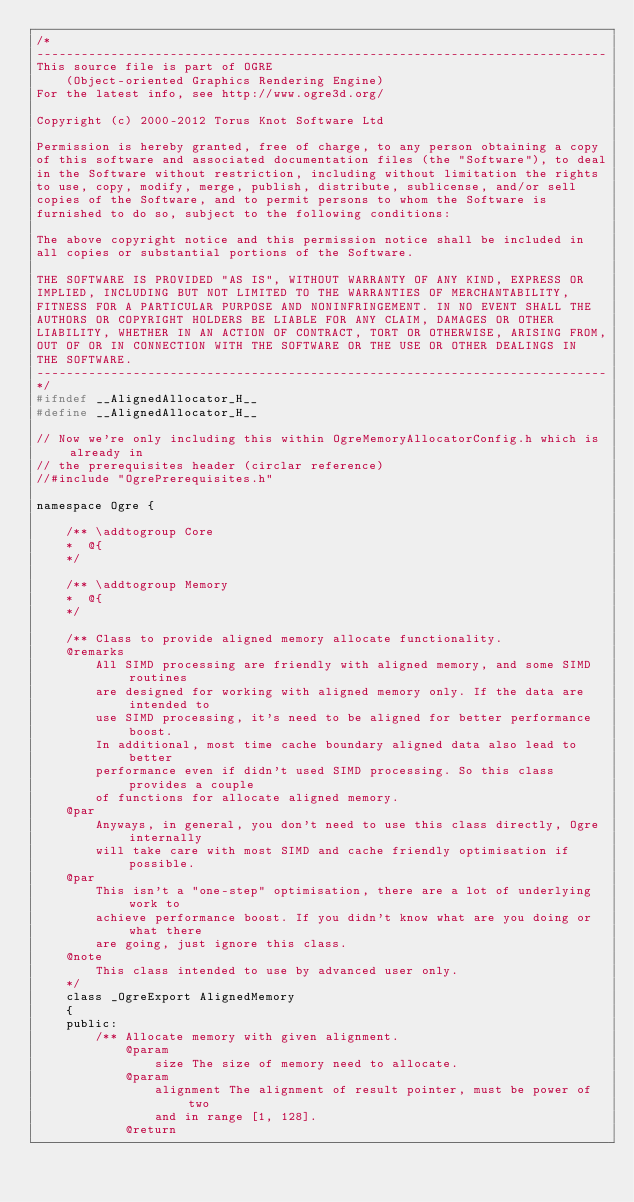Convert code to text. <code><loc_0><loc_0><loc_500><loc_500><_C_>/*
-----------------------------------------------------------------------------
This source file is part of OGRE
    (Object-oriented Graphics Rendering Engine)
For the latest info, see http://www.ogre3d.org/

Copyright (c) 2000-2012 Torus Knot Software Ltd

Permission is hereby granted, free of charge, to any person obtaining a copy
of this software and associated documentation files (the "Software"), to deal
in the Software without restriction, including without limitation the rights
to use, copy, modify, merge, publish, distribute, sublicense, and/or sell
copies of the Software, and to permit persons to whom the Software is
furnished to do so, subject to the following conditions:

The above copyright notice and this permission notice shall be included in
all copies or substantial portions of the Software.

THE SOFTWARE IS PROVIDED "AS IS", WITHOUT WARRANTY OF ANY KIND, EXPRESS OR
IMPLIED, INCLUDING BUT NOT LIMITED TO THE WARRANTIES OF MERCHANTABILITY,
FITNESS FOR A PARTICULAR PURPOSE AND NONINFRINGEMENT. IN NO EVENT SHALL THE
AUTHORS OR COPYRIGHT HOLDERS BE LIABLE FOR ANY CLAIM, DAMAGES OR OTHER
LIABILITY, WHETHER IN AN ACTION OF CONTRACT, TORT OR OTHERWISE, ARISING FROM,
OUT OF OR IN CONNECTION WITH THE SOFTWARE OR THE USE OR OTHER DEALINGS IN
THE SOFTWARE.
-----------------------------------------------------------------------------
*/
#ifndef __AlignedAllocator_H__
#define __AlignedAllocator_H__

// Now we're only including this within OgreMemoryAllocatorConfig.h which is already in
// the prerequisites header (circlar reference)
//#include "OgrePrerequisites.h"

namespace Ogre {

	/** \addtogroup Core
	*  @{
	*/

	/** \addtogroup Memory
	*  @{
	*/

	/** Class to provide aligned memory allocate functionality.
    @remarks
        All SIMD processing are friendly with aligned memory, and some SIMD routines
        are designed for working with aligned memory only. If the data are intended to
        use SIMD processing, it's need to be aligned for better performance boost.
        In additional, most time cache boundary aligned data also lead to better
        performance even if didn't used SIMD processing. So this class provides a couple
        of functions for allocate aligned memory.
    @par
        Anyways, in general, you don't need to use this class directly, Ogre internally
        will take care with most SIMD and cache friendly optimisation if possible.
    @par
        This isn't a "one-step" optimisation, there are a lot of underlying work to
        achieve performance boost. If you didn't know what are you doing or what there
        are going, just ignore this class.
    @note
        This class intended to use by advanced user only.
    */
	class _OgreExport AlignedMemory
	{
	public:
        /** Allocate memory with given alignment.
            @param
                size The size of memory need to allocate.
            @param
                alignment The alignment of result pointer, must be power of two
                and in range [1, 128].
            @return</code> 